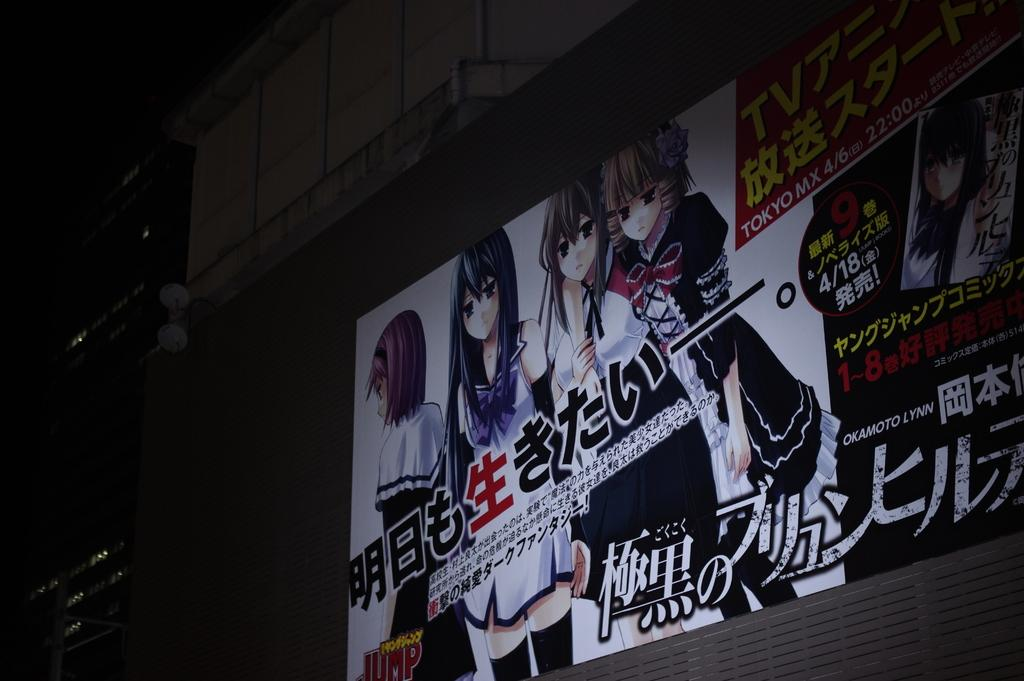What is hanging or displayed in the image? There is a banner in the image. What type of structures can be seen in the image? There are buildings in the image. What can be seen illuminating the scene in the image? There are lights in the image. Can you describe any other objects present in the image? There are some objects in the image. How would you describe the overall appearance of the image? The background of the image is dark. What type of hat is the person wearing in the image? There is no person wearing a hat in the image; it only features a banner, buildings, lights, and objects. Is there any smoke visible in the image? There is no smoke present in the image. 